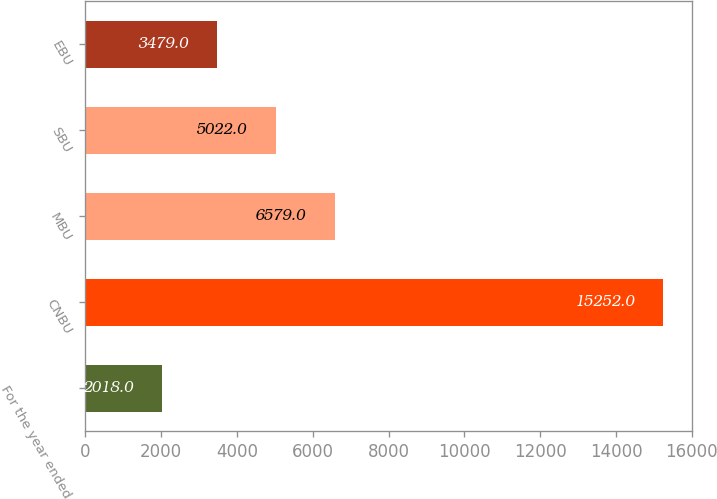Convert chart to OTSL. <chart><loc_0><loc_0><loc_500><loc_500><bar_chart><fcel>For the year ended<fcel>CNBU<fcel>MBU<fcel>SBU<fcel>EBU<nl><fcel>2018<fcel>15252<fcel>6579<fcel>5022<fcel>3479<nl></chart> 